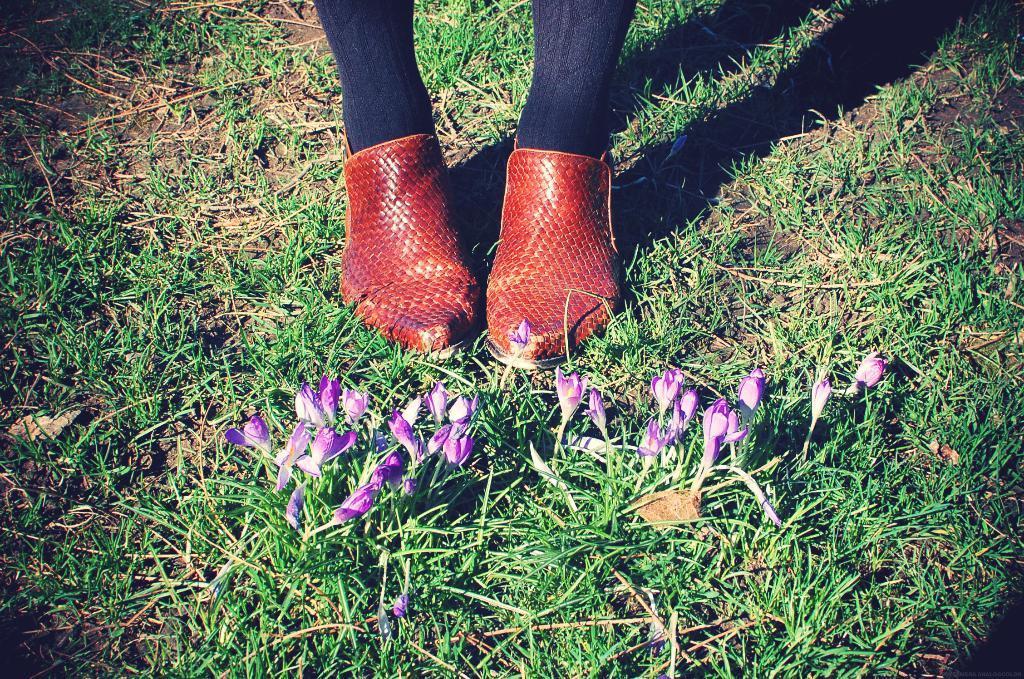Could you give a brief overview of what you see in this image? This is grass and there are flowers. Here we can see legs of a person and shoes. 